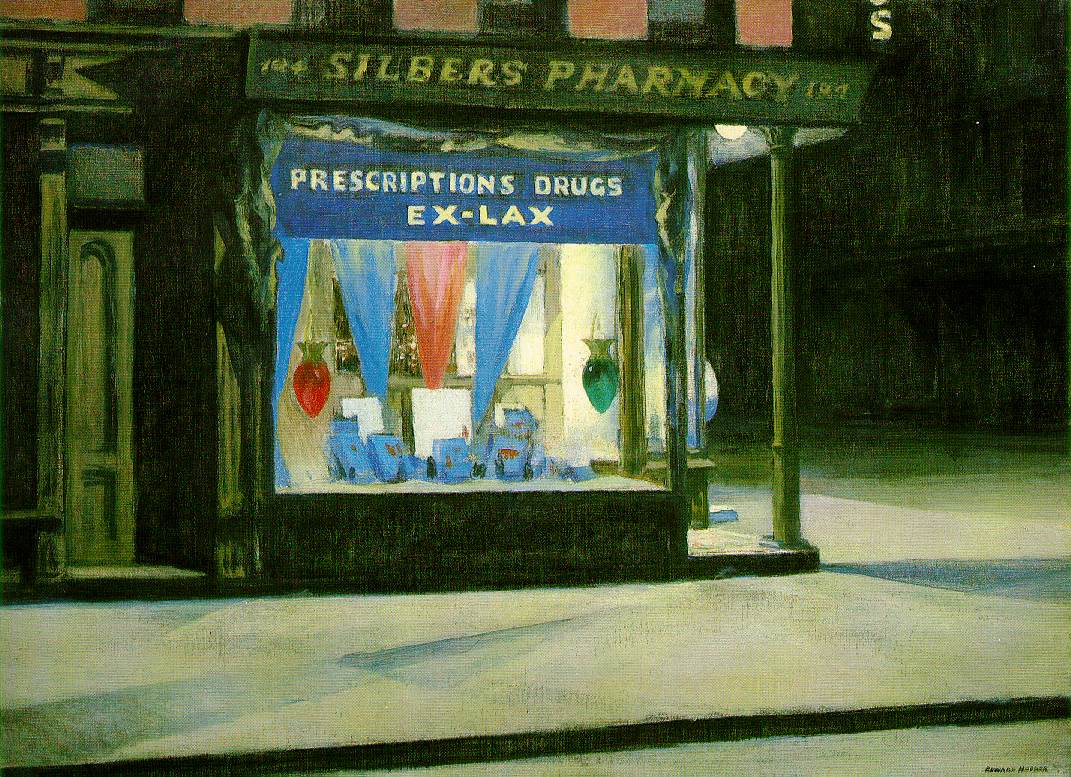Can you tell me more about the historical significance of pharmacies like Silber's in urban settings? Pharmacies such as Silber's have played a crucial role in urban settings, acting not just as medical supply stores but as integral parts of the community. Historically, pharmacies were often family-owned businesses, passed down through generations, providing essential medicines and health care products. They were also places of personal interaction where pharmacists offered advice, support, and a sense of community care. The architectural presence of such pharmacies contributed to the local landscape, often featuring distinct signage and colorful displays to attract passersby. This historical role of the pharmacy in urban settings reflects a blend of commerce, healthcare, and community engagement, which were vital for the functioning and well-being of urban populations. 